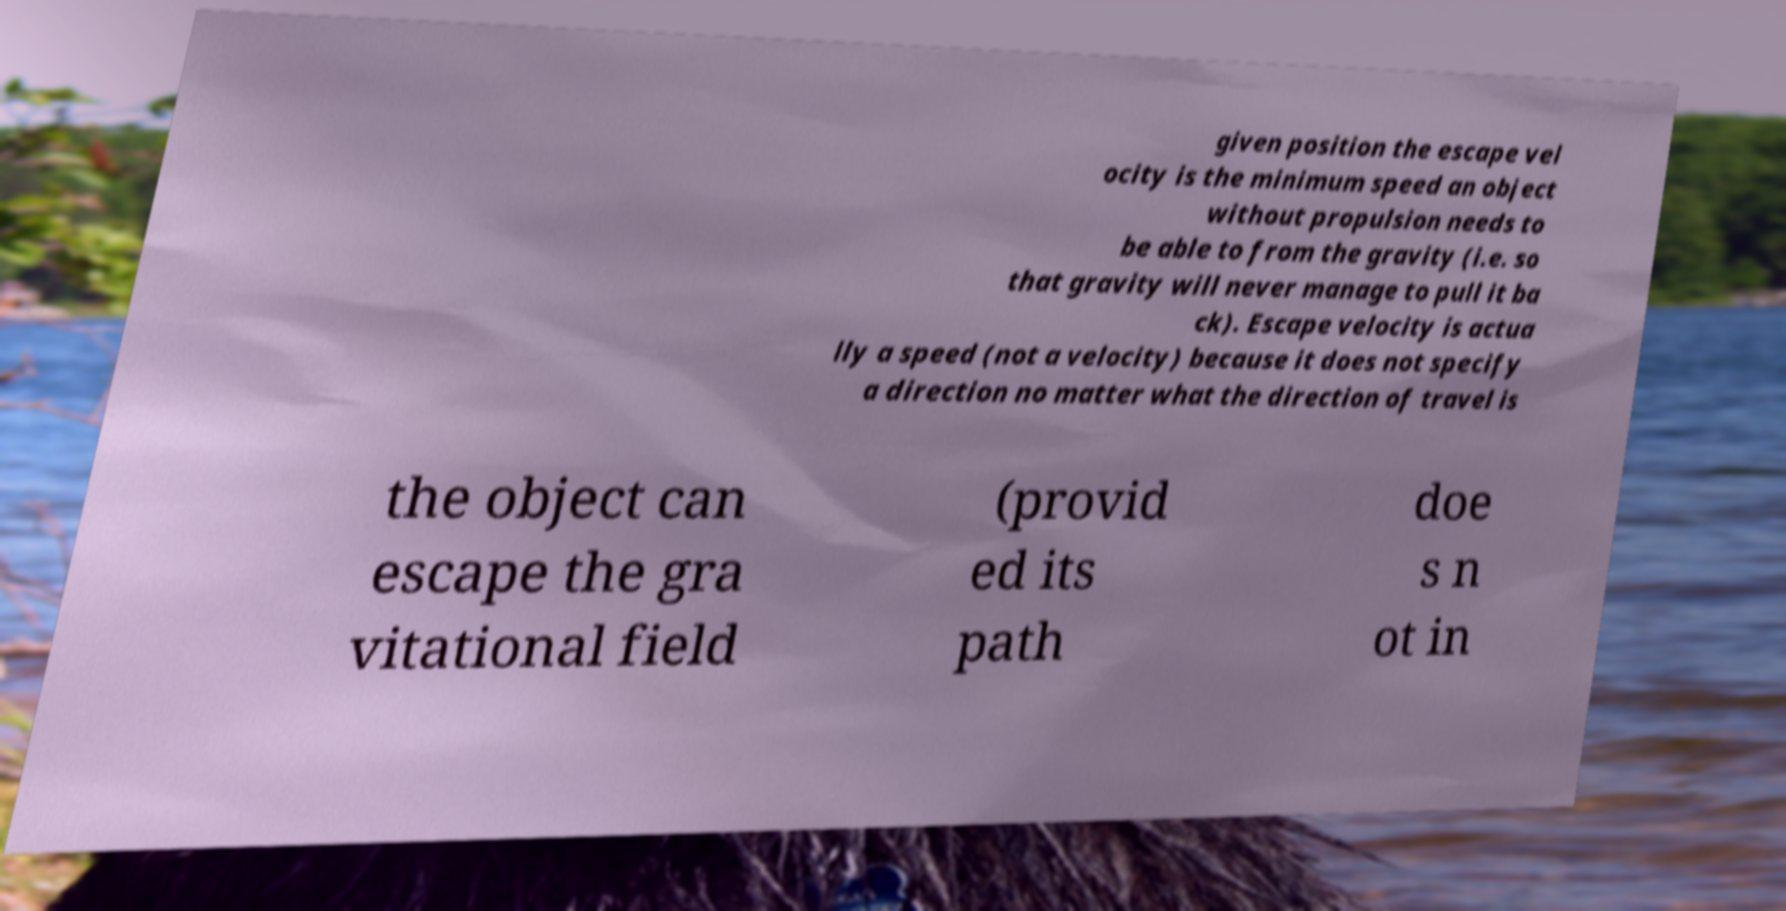Please read and relay the text visible in this image. What does it say? given position the escape vel ocity is the minimum speed an object without propulsion needs to be able to from the gravity (i.e. so that gravity will never manage to pull it ba ck). Escape velocity is actua lly a speed (not a velocity) because it does not specify a direction no matter what the direction of travel is the object can escape the gra vitational field (provid ed its path doe s n ot in 